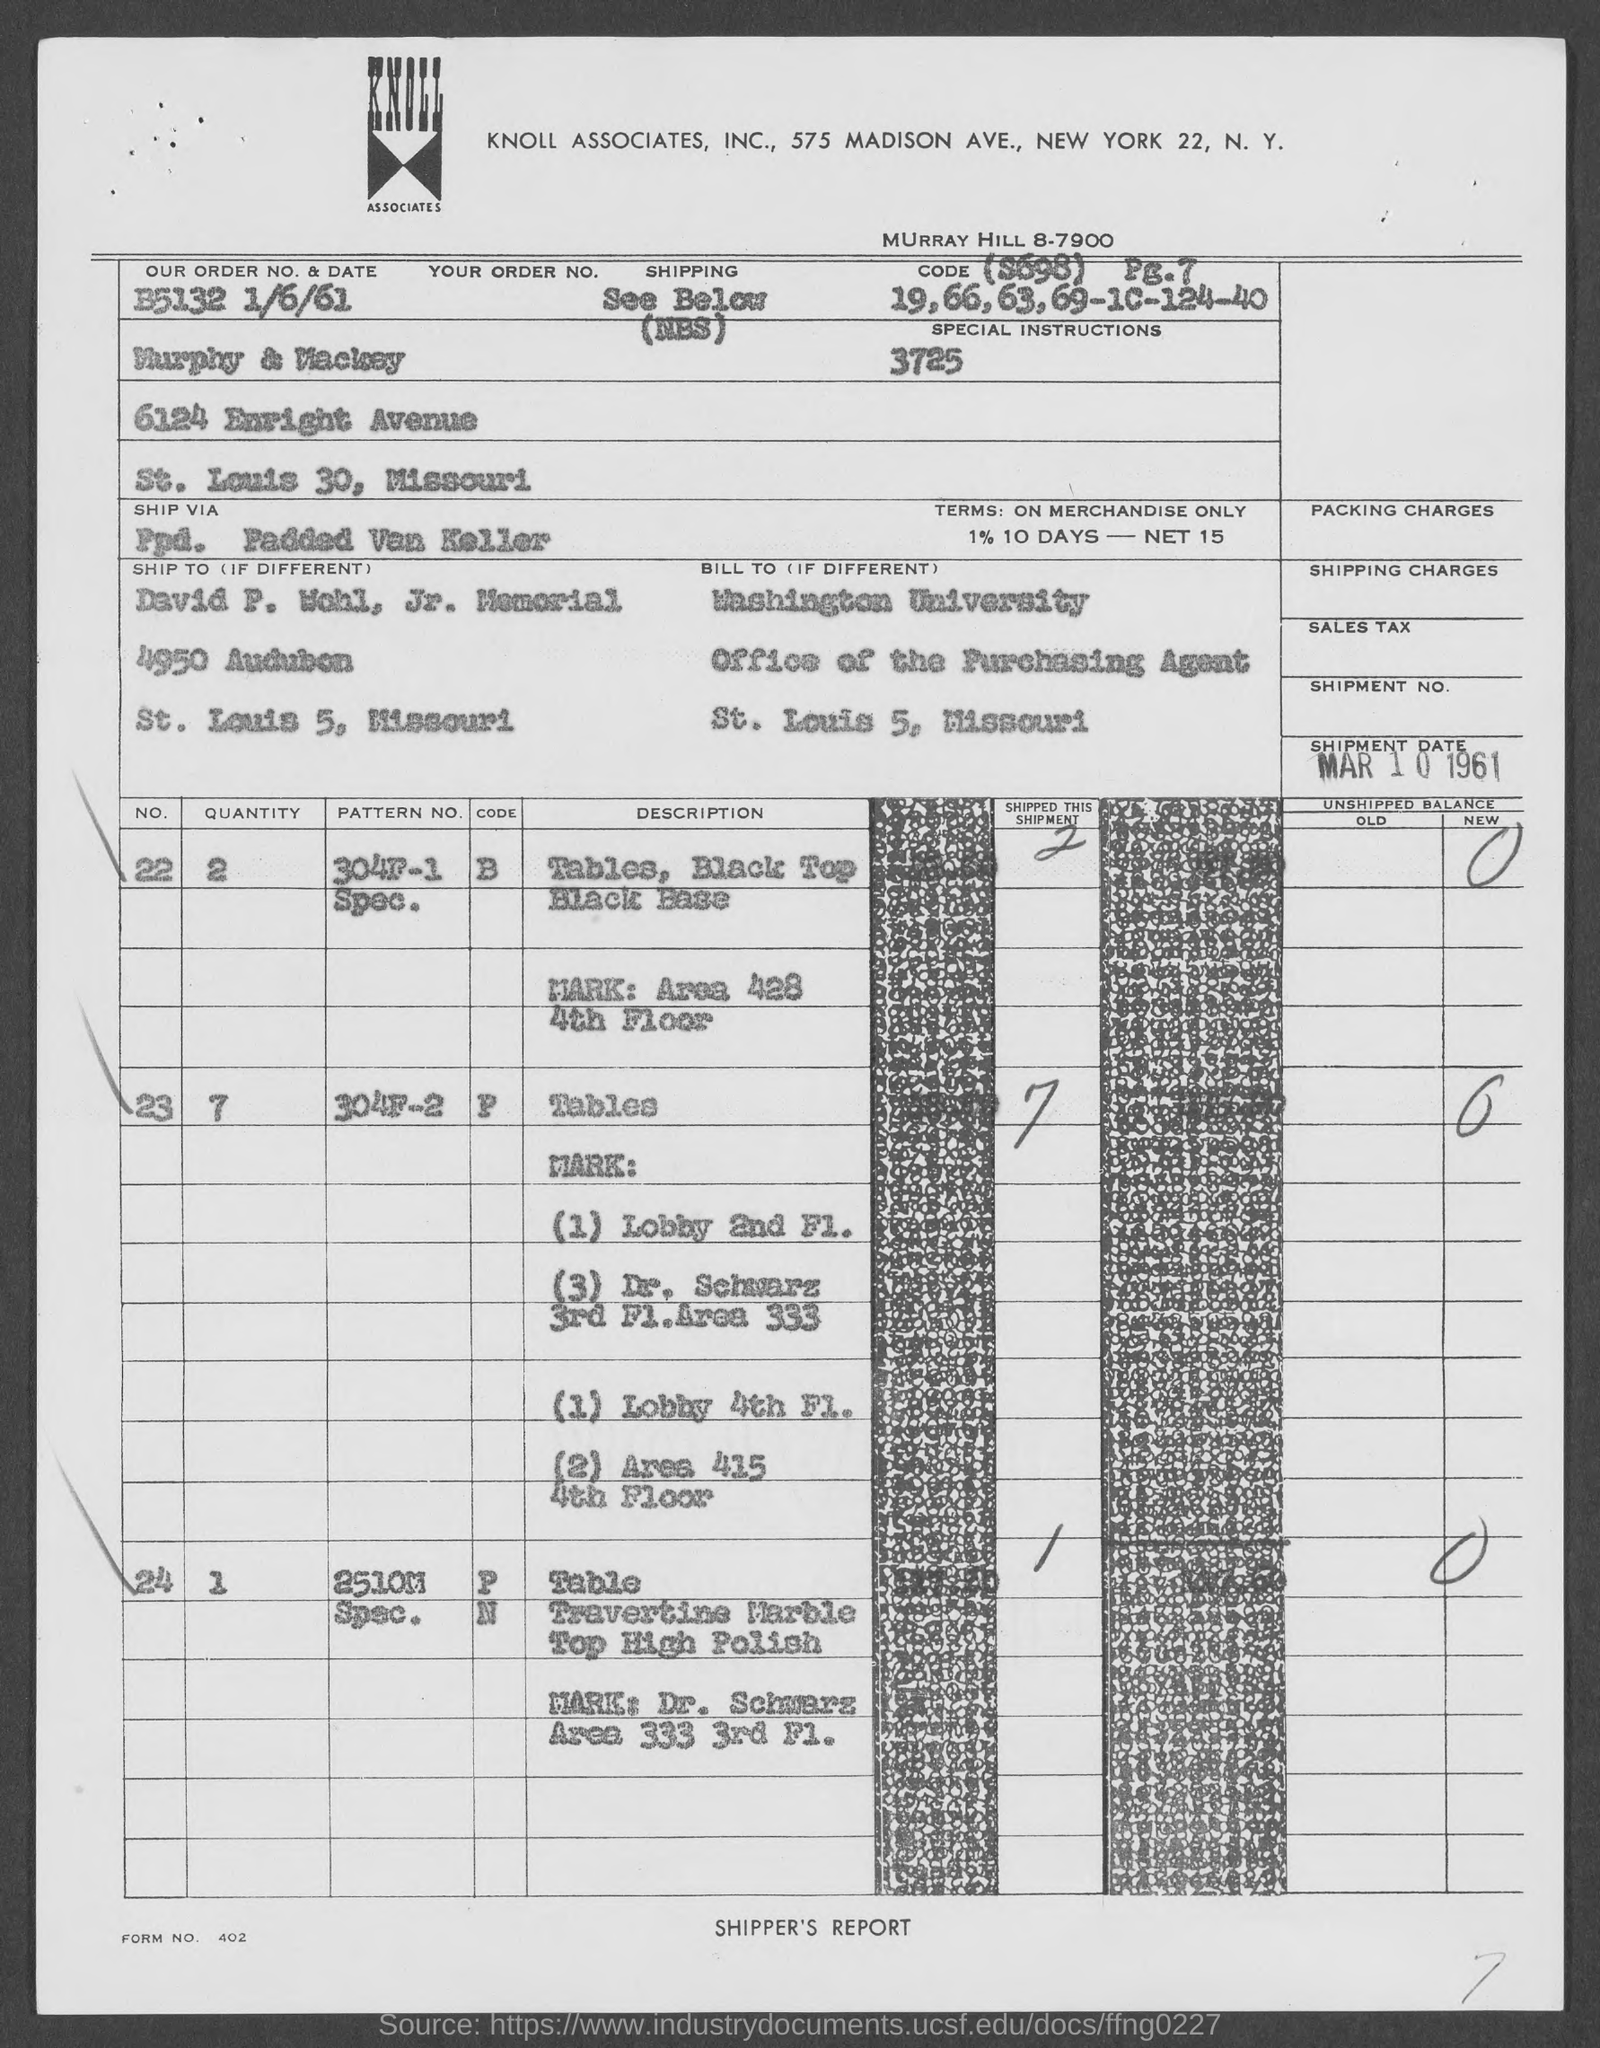Identify some key points in this picture. The order number is B5132 and the date mentioned in the document is 1/6/61. The billing address contains the name of the university that is Washington University. The company mentioned in the header of the document is Knoll Associates, Inc. The shipment date, as mentioned in the document, is March 10, 1961. What is the form number listed in the document? 